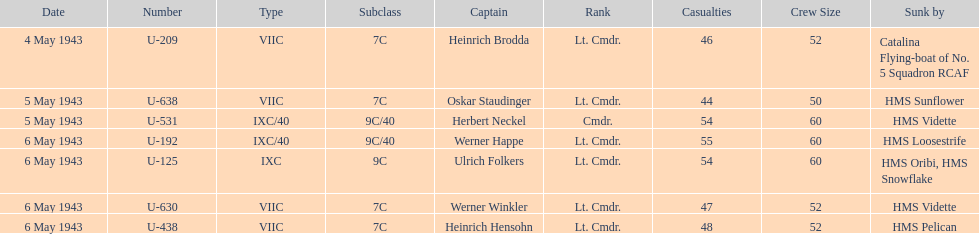Could you parse the entire table as a dict? {'header': ['Date', 'Number', 'Type', 'Subclass', 'Captain', 'Rank', 'Casualties', 'Crew Size', 'Sunk by'], 'rows': [['4 May 1943', 'U-209', 'VIIC', '7C', 'Heinrich Brodda', 'Lt. Cmdr.', '46', '52', 'Catalina Flying-boat of No. 5 Squadron RCAF'], ['5 May 1943', 'U-638', 'VIIC', '7C', 'Oskar Staudinger', 'Lt. Cmdr.', '44', '50', 'HMS Sunflower'], ['5 May 1943', 'U-531', 'IXC/40', '9C/40', 'Herbert Neckel', 'Cmdr.', '54', '60', 'HMS Vidette'], ['6 May 1943', 'U-192', 'IXC/40', '9C/40', 'Werner Happe', 'Lt. Cmdr.', '55', '60', 'HMS Loosestrife'], ['6 May 1943', 'U-125', 'IXC', '9C', 'Ulrich Folkers', 'Lt. Cmdr.', '54', '60', 'HMS Oribi, HMS Snowflake'], ['6 May 1943', 'U-630', 'VIIC', '7C', 'Werner Winkler', 'Lt. Cmdr.', '47', '52', 'HMS Vidette'], ['6 May 1943', 'U-438', 'VIIC', '7C', 'Heinrich Hensohn', 'Lt. Cmdr.', '48', '52', 'HMS Pelican']]} What was the number of casualties on may 4 1943? 46. 